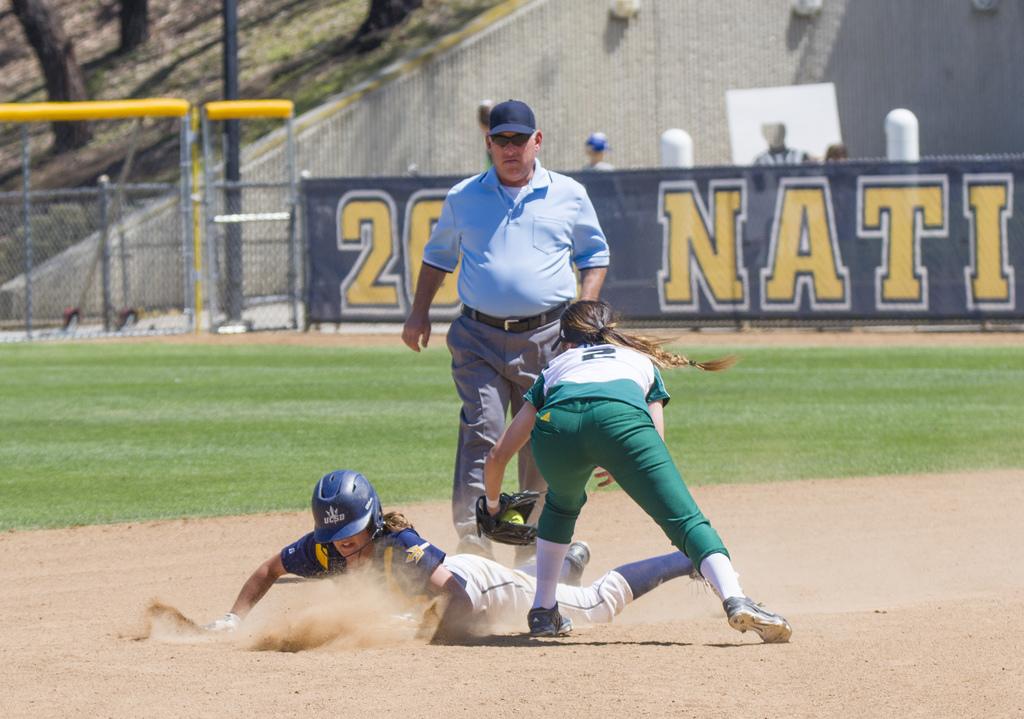What does the banner say?
Provide a short and direct response. Unanswerable. 